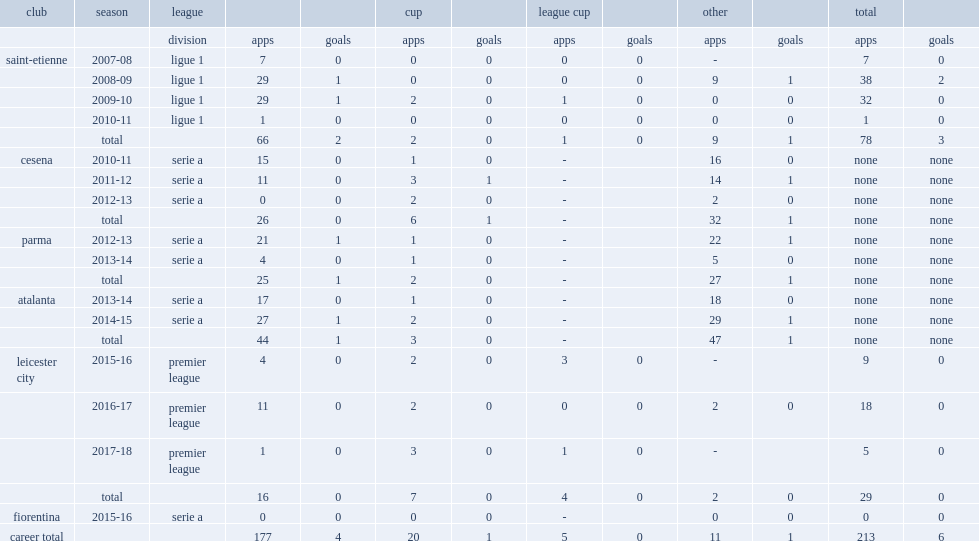Which division did benalouane play for in 2016-17 season? Premier league. 